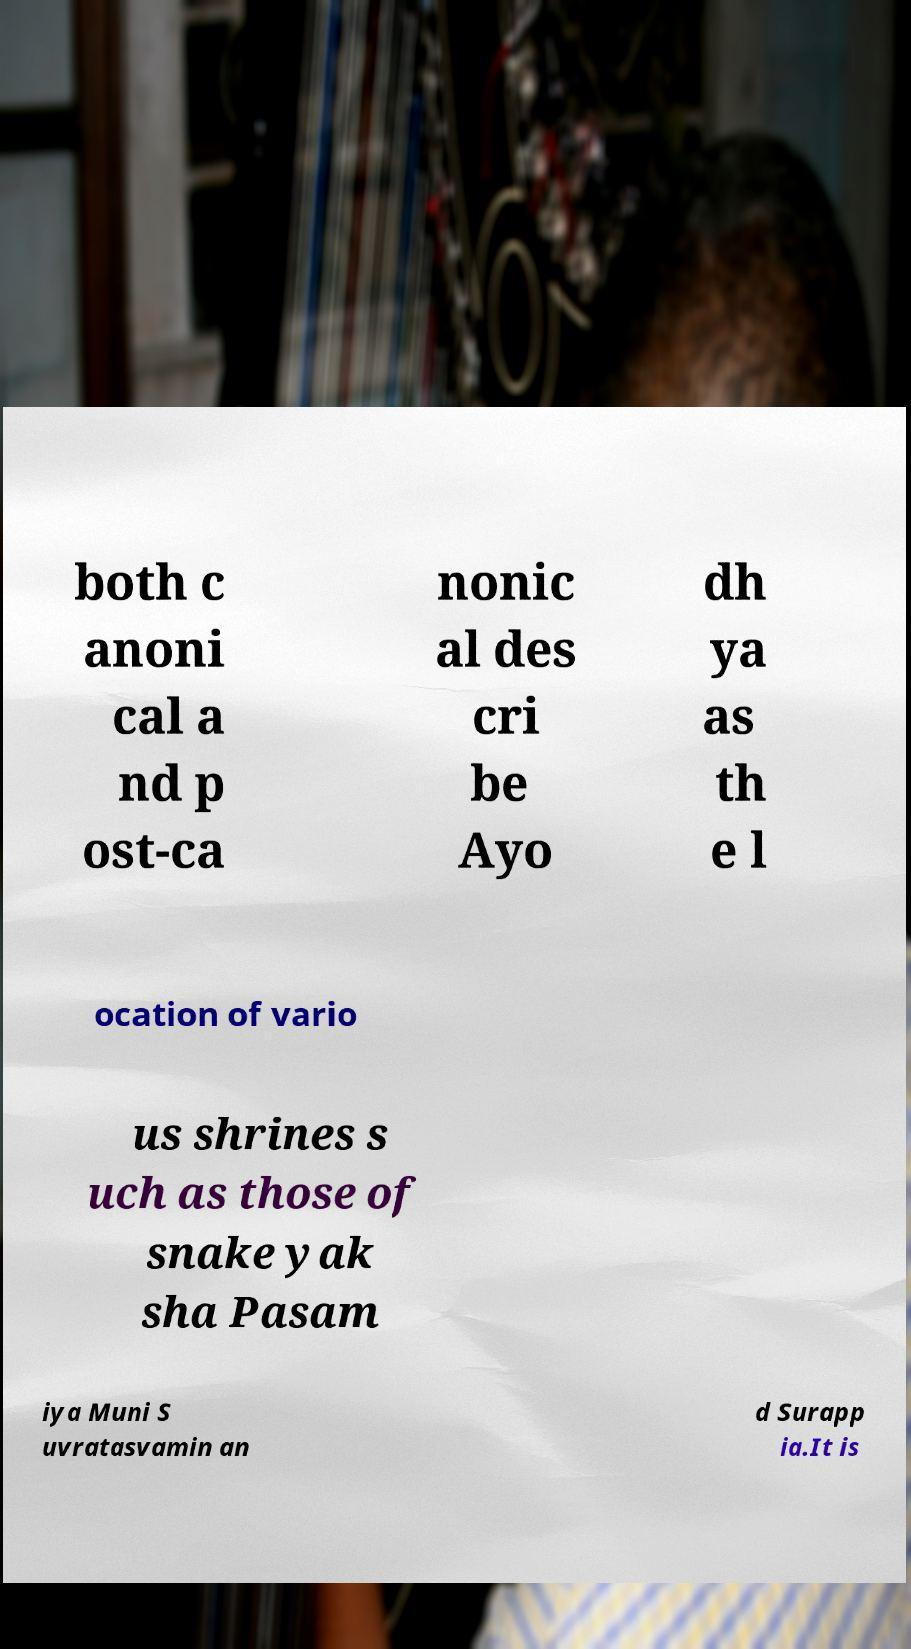What messages or text are displayed in this image? I need them in a readable, typed format. both c anoni cal a nd p ost-ca nonic al des cri be Ayo dh ya as th e l ocation of vario us shrines s uch as those of snake yak sha Pasam iya Muni S uvratasvamin an d Surapp ia.It is 